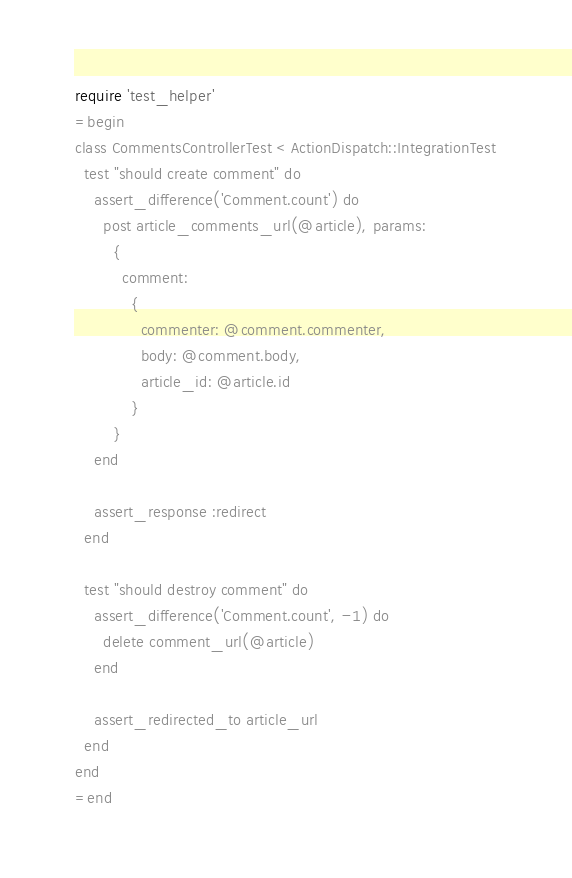Convert code to text. <code><loc_0><loc_0><loc_500><loc_500><_Ruby_>require 'test_helper'
=begin
class CommentsControllerTest < ActionDispatch::IntegrationTest
  test "should create comment" do
    assert_difference('Comment.count') do
      post article_comments_url(@article), params:
        {
          comment:
            {
              commenter: @comment.commenter,
              body: @comment.body,
              article_id: @article.id
            }
        }
    end

    assert_response :redirect
  end

  test "should destroy comment" do
    assert_difference('Comment.count', -1) do
      delete comment_url(@article)
    end

    assert_redirected_to article_url
  end
end
=end</code> 